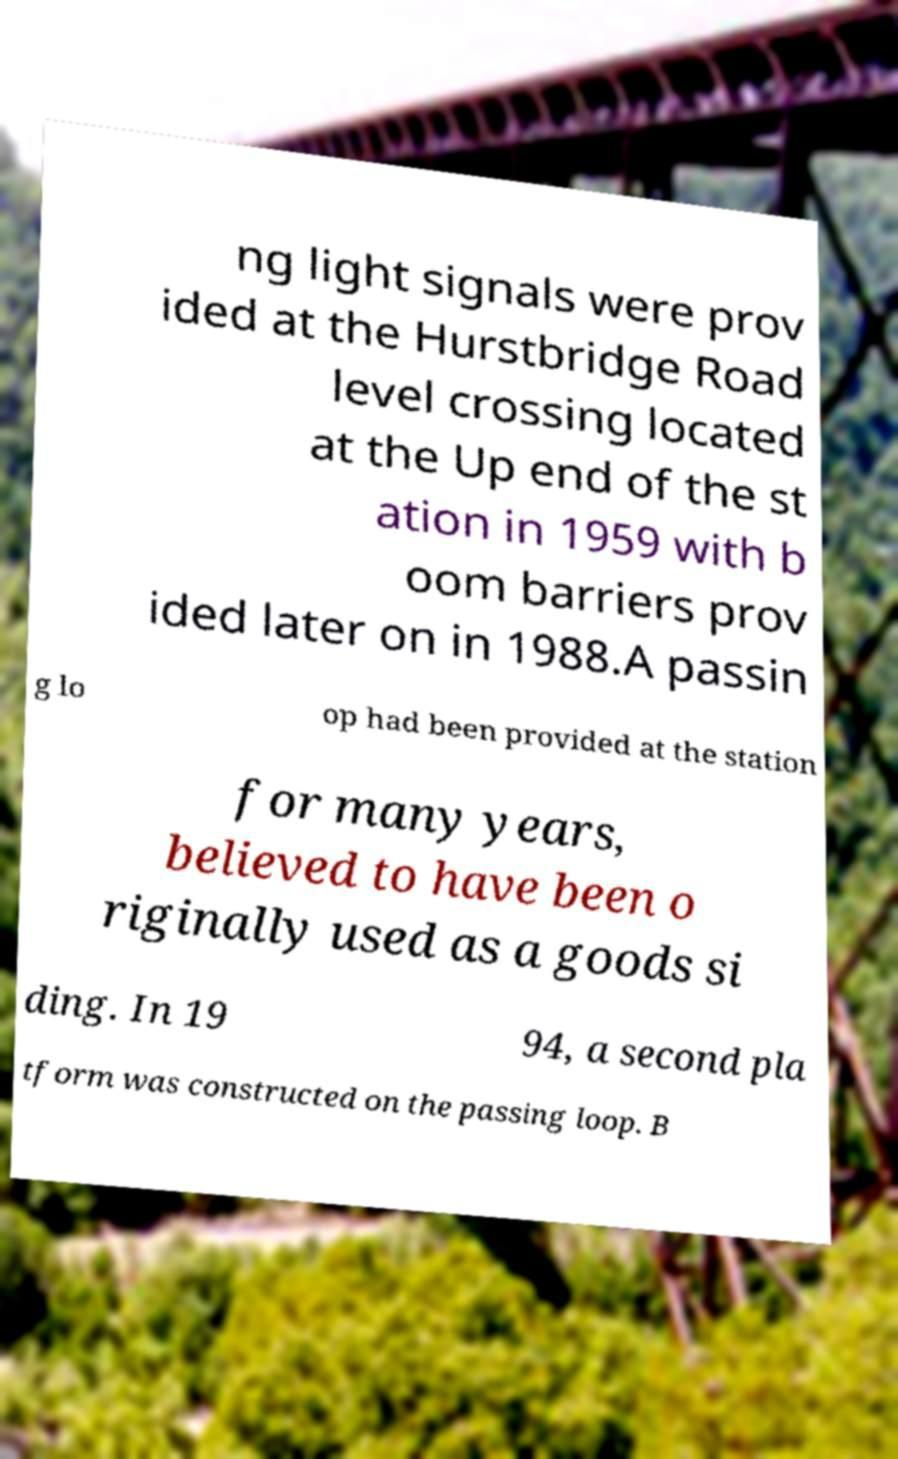Can you read and provide the text displayed in the image?This photo seems to have some interesting text. Can you extract and type it out for me? ng light signals were prov ided at the Hurstbridge Road level crossing located at the Up end of the st ation in 1959 with b oom barriers prov ided later on in 1988.A passin g lo op had been provided at the station for many years, believed to have been o riginally used as a goods si ding. In 19 94, a second pla tform was constructed on the passing loop. B 